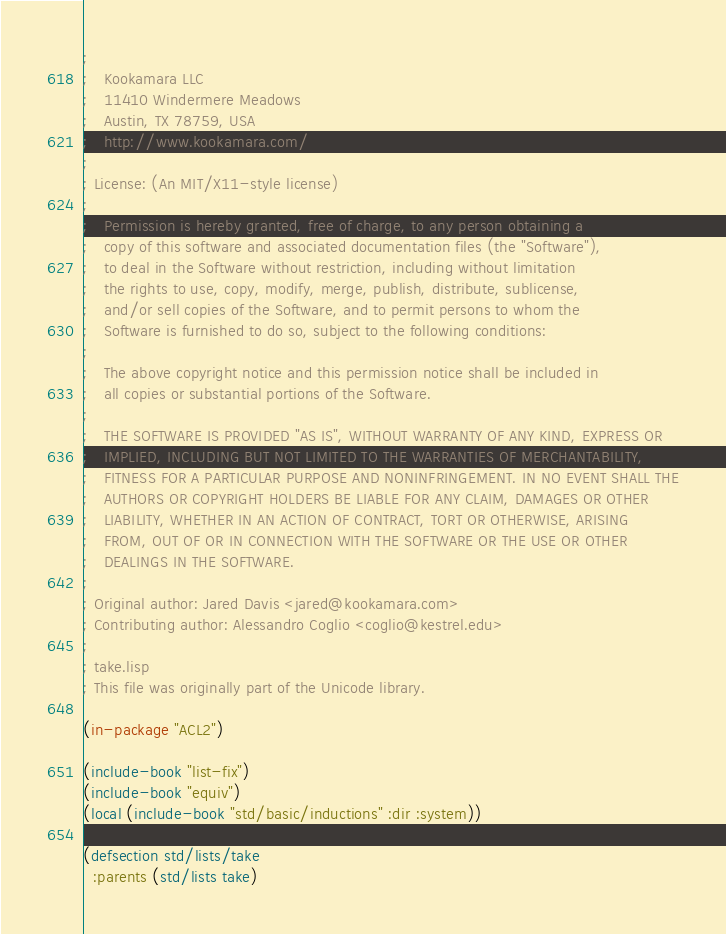Convert code to text. <code><loc_0><loc_0><loc_500><loc_500><_Lisp_>;
;   Kookamara LLC
;   11410 Windermere Meadows
;   Austin, TX 78759, USA
;   http://www.kookamara.com/
;
; License: (An MIT/X11-style license)
;
;   Permission is hereby granted, free of charge, to any person obtaining a
;   copy of this software and associated documentation files (the "Software"),
;   to deal in the Software without restriction, including without limitation
;   the rights to use, copy, modify, merge, publish, distribute, sublicense,
;   and/or sell copies of the Software, and to permit persons to whom the
;   Software is furnished to do so, subject to the following conditions:
;
;   The above copyright notice and this permission notice shall be included in
;   all copies or substantial portions of the Software.
;
;   THE SOFTWARE IS PROVIDED "AS IS", WITHOUT WARRANTY OF ANY KIND, EXPRESS OR
;   IMPLIED, INCLUDING BUT NOT LIMITED TO THE WARRANTIES OF MERCHANTABILITY,
;   FITNESS FOR A PARTICULAR PURPOSE AND NONINFRINGEMENT. IN NO EVENT SHALL THE
;   AUTHORS OR COPYRIGHT HOLDERS BE LIABLE FOR ANY CLAIM, DAMAGES OR OTHER
;   LIABILITY, WHETHER IN AN ACTION OF CONTRACT, TORT OR OTHERWISE, ARISING
;   FROM, OUT OF OR IN CONNECTION WITH THE SOFTWARE OR THE USE OR OTHER
;   DEALINGS IN THE SOFTWARE.
;
; Original author: Jared Davis <jared@kookamara.com>
; Contributing author: Alessandro Coglio <coglio@kestrel.edu>
;
; take.lisp
; This file was originally part of the Unicode library.

(in-package "ACL2")

(include-book "list-fix")
(include-book "equiv")
(local (include-book "std/basic/inductions" :dir :system))

(defsection std/lists/take
  :parents (std/lists take)</code> 